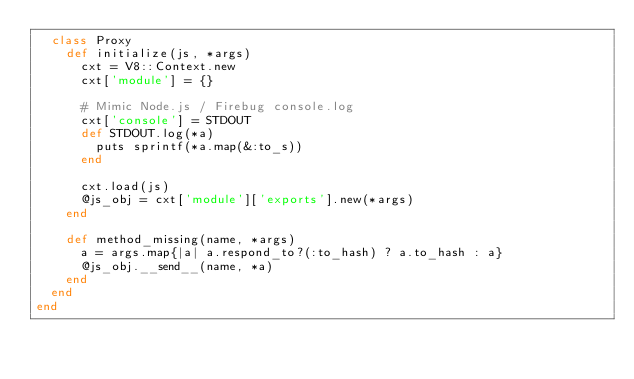Convert code to text. <code><loc_0><loc_0><loc_500><loc_500><_Ruby_>  class Proxy
    def initialize(js, *args)
      cxt = V8::Context.new
      cxt['module'] = {}

      # Mimic Node.js / Firebug console.log
      cxt['console'] = STDOUT
      def STDOUT.log(*a)
        puts sprintf(*a.map(&:to_s))
      end

      cxt.load(js)
      @js_obj = cxt['module']['exports'].new(*args)
    end

    def method_missing(name, *args)
      a = args.map{|a| a.respond_to?(:to_hash) ? a.to_hash : a}
      @js_obj.__send__(name, *a)
    end
  end
end
</code> 